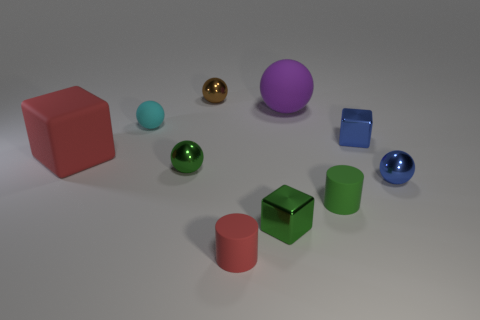What shape is the thing that is the same color as the large rubber block?
Ensure brevity in your answer.  Cylinder. How many rubber things are either blue cubes or small cyan blocks?
Offer a very short reply. 0. What is the material of the tiny cylinder on the left side of the green object that is to the right of the big ball?
Your answer should be compact. Rubber. Are there more small matte objects that are in front of the big matte block than yellow metal things?
Provide a succinct answer. Yes. Is there a cyan sphere that has the same material as the big purple ball?
Ensure brevity in your answer.  Yes. Is the shape of the small blue metallic thing in front of the red matte block the same as  the green matte object?
Give a very brief answer. No. There is a metal thing in front of the blue thing in front of the rubber block; what number of tiny cylinders are in front of it?
Provide a succinct answer. 1. Are there fewer tiny metallic objects that are behind the small cyan thing than tiny rubber objects that are left of the small green cylinder?
Your response must be concise. Yes. The other matte thing that is the same shape as the green rubber object is what color?
Offer a very short reply. Red. The brown metallic thing is what size?
Provide a short and direct response. Small. 